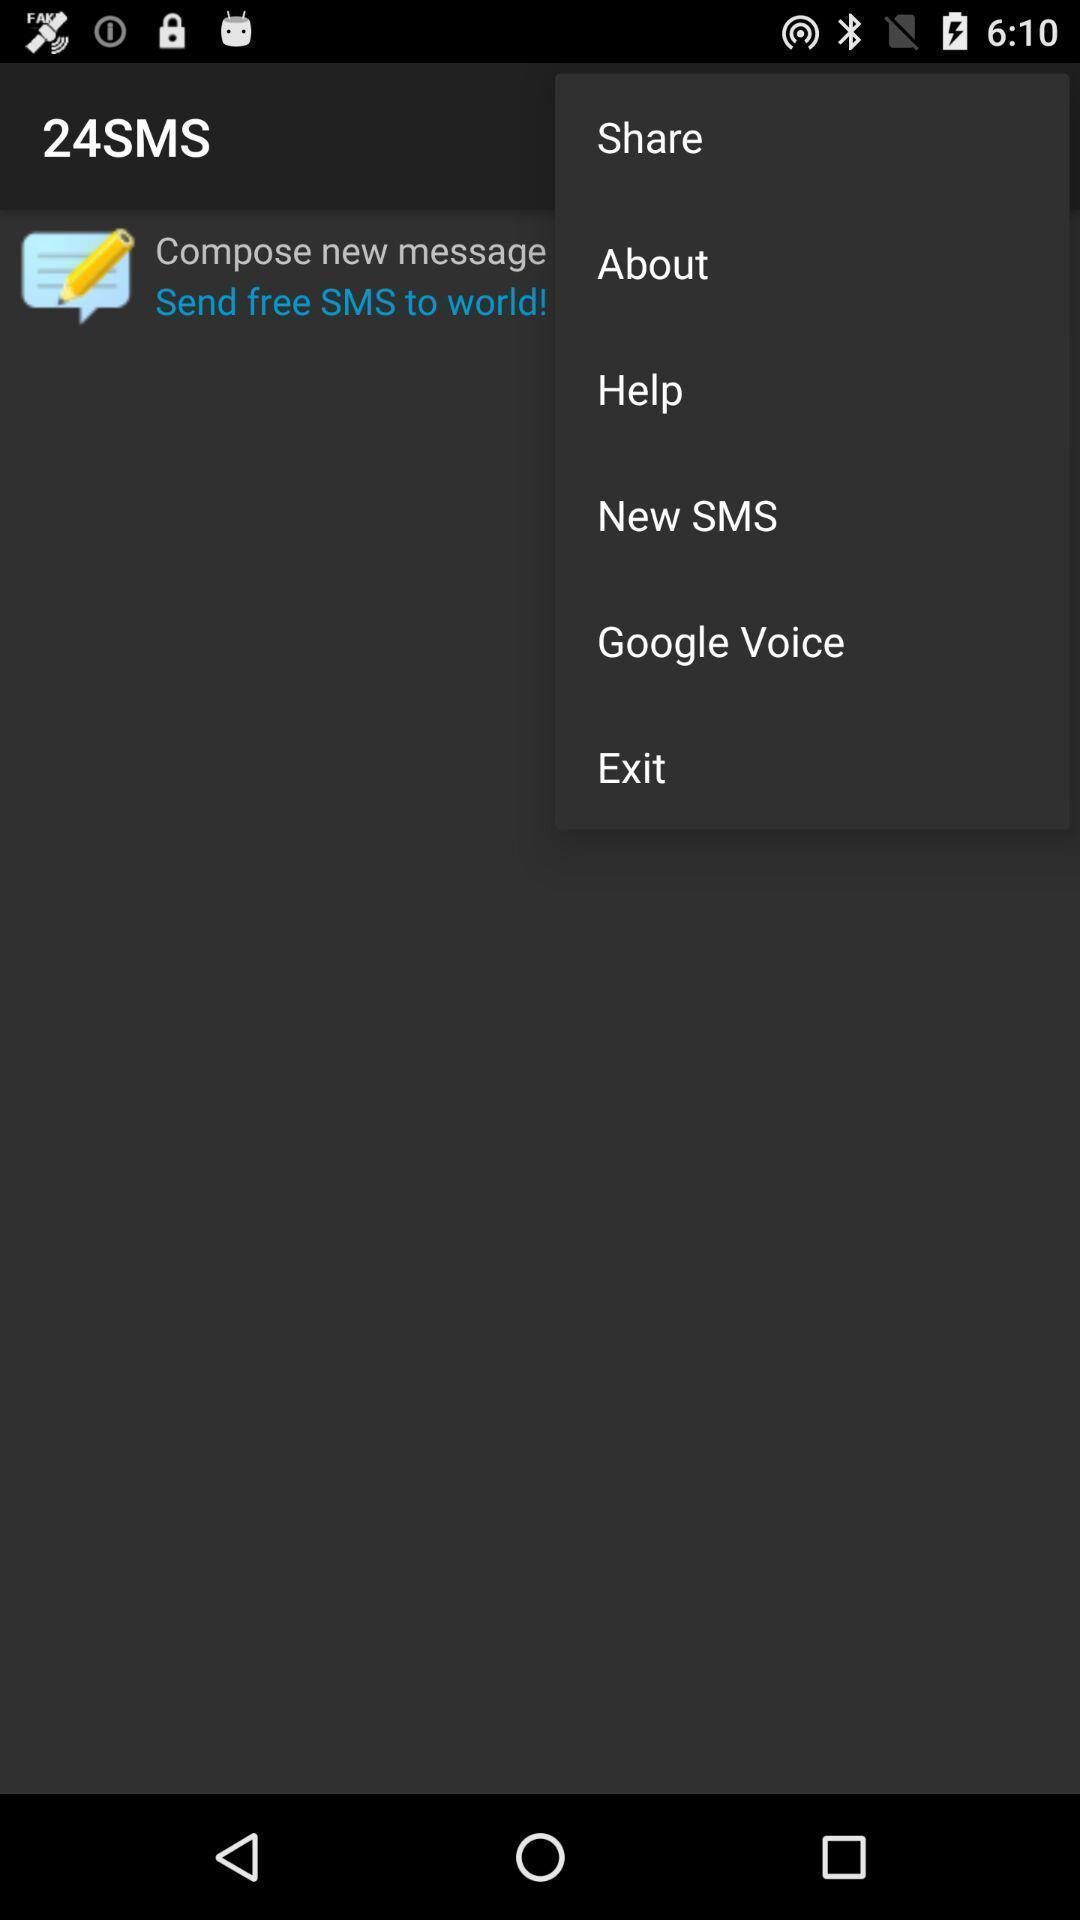What can you discern from this picture? Page displaying with list of different options. 